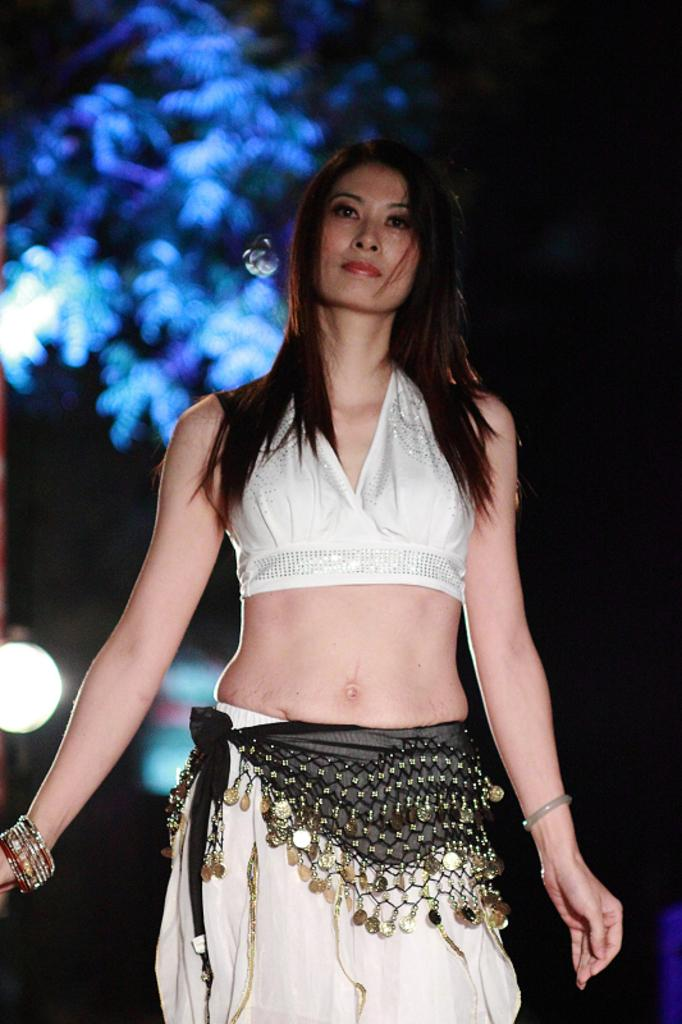Who is present in the image? There is a woman in the image. What is the woman wearing? The woman is wearing a white dress. What can be seen in the background of the image? There is a tree in the background of the image. How is the tree illuminated in the image? The tree has blue light on it. How many bears are sitting in the crib in the image? There are no bears or cribs present in the image. 